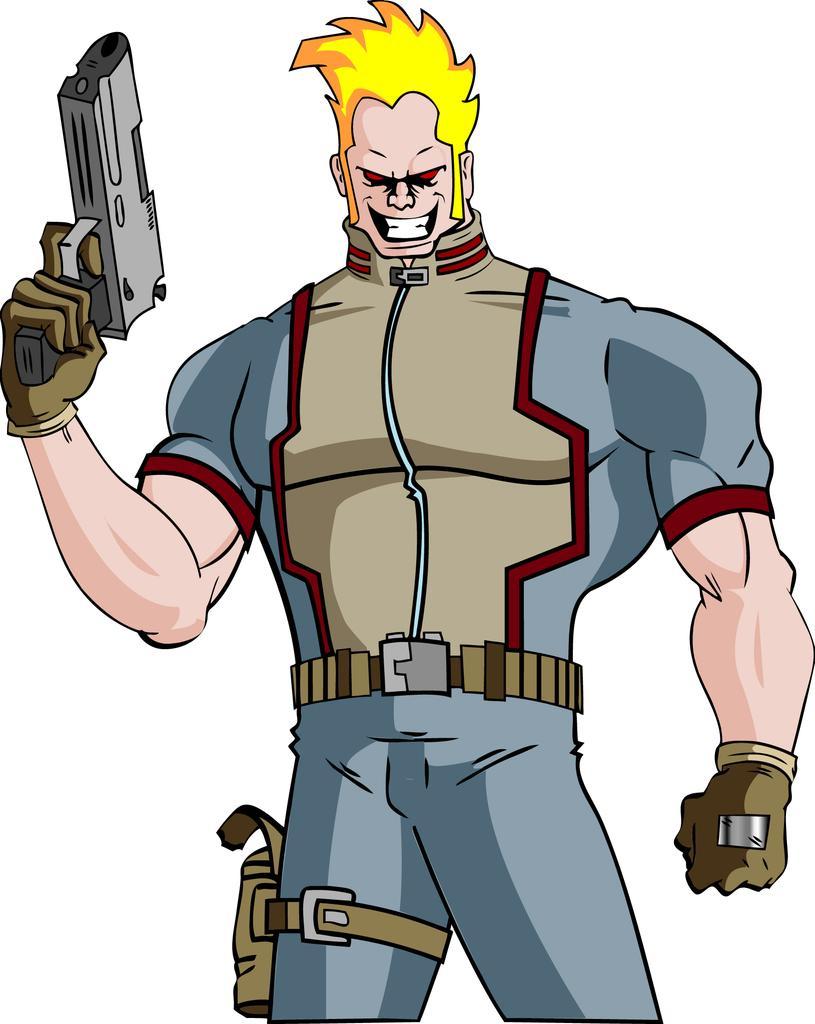Could you give a brief overview of what you see in this image? In this image there is a cartoon picture. 